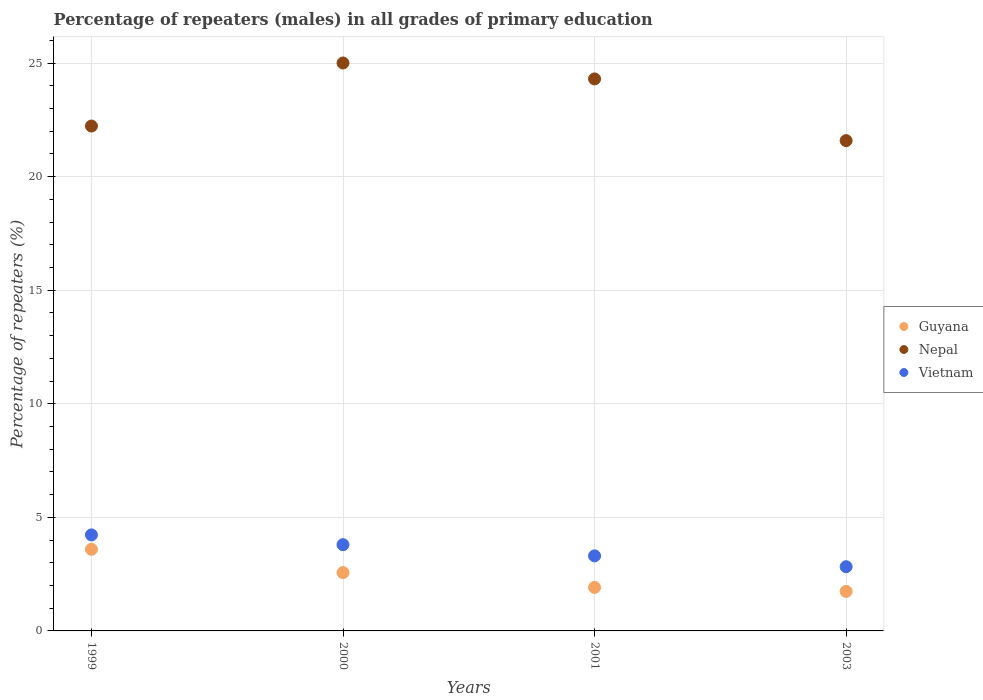How many different coloured dotlines are there?
Keep it short and to the point. 3. What is the percentage of repeaters (males) in Guyana in 2000?
Ensure brevity in your answer.  2.57. Across all years, what is the maximum percentage of repeaters (males) in Guyana?
Make the answer very short. 3.59. Across all years, what is the minimum percentage of repeaters (males) in Guyana?
Make the answer very short. 1.74. In which year was the percentage of repeaters (males) in Guyana minimum?
Offer a very short reply. 2003. What is the total percentage of repeaters (males) in Nepal in the graph?
Your answer should be very brief. 93.11. What is the difference between the percentage of repeaters (males) in Vietnam in 1999 and that in 2001?
Your response must be concise. 0.92. What is the difference between the percentage of repeaters (males) in Guyana in 1999 and the percentage of repeaters (males) in Vietnam in 2001?
Keep it short and to the point. 0.29. What is the average percentage of repeaters (males) in Guyana per year?
Provide a succinct answer. 2.45. In the year 2000, what is the difference between the percentage of repeaters (males) in Nepal and percentage of repeaters (males) in Vietnam?
Give a very brief answer. 21.2. In how many years, is the percentage of repeaters (males) in Nepal greater than 22 %?
Offer a very short reply. 3. What is the ratio of the percentage of repeaters (males) in Vietnam in 1999 to that in 2003?
Provide a succinct answer. 1.5. Is the percentage of repeaters (males) in Guyana in 2000 less than that in 2003?
Provide a short and direct response. No. What is the difference between the highest and the second highest percentage of repeaters (males) in Guyana?
Keep it short and to the point. 1.02. What is the difference between the highest and the lowest percentage of repeaters (males) in Nepal?
Make the answer very short. 3.42. In how many years, is the percentage of repeaters (males) in Vietnam greater than the average percentage of repeaters (males) in Vietnam taken over all years?
Ensure brevity in your answer.  2. Is the sum of the percentage of repeaters (males) in Vietnam in 1999 and 2000 greater than the maximum percentage of repeaters (males) in Nepal across all years?
Make the answer very short. No. Is it the case that in every year, the sum of the percentage of repeaters (males) in Nepal and percentage of repeaters (males) in Vietnam  is greater than the percentage of repeaters (males) in Guyana?
Your response must be concise. Yes. Does the percentage of repeaters (males) in Vietnam monotonically increase over the years?
Keep it short and to the point. No. Is the percentage of repeaters (males) in Guyana strictly greater than the percentage of repeaters (males) in Nepal over the years?
Make the answer very short. No. Is the percentage of repeaters (males) in Vietnam strictly less than the percentage of repeaters (males) in Nepal over the years?
Offer a terse response. Yes. How many dotlines are there?
Your answer should be compact. 3. What is the difference between two consecutive major ticks on the Y-axis?
Offer a terse response. 5. Are the values on the major ticks of Y-axis written in scientific E-notation?
Ensure brevity in your answer.  No. Does the graph contain any zero values?
Offer a terse response. No. How are the legend labels stacked?
Ensure brevity in your answer.  Vertical. What is the title of the graph?
Your answer should be very brief. Percentage of repeaters (males) in all grades of primary education. Does "United States" appear as one of the legend labels in the graph?
Offer a very short reply. No. What is the label or title of the X-axis?
Give a very brief answer. Years. What is the label or title of the Y-axis?
Keep it short and to the point. Percentage of repeaters (%). What is the Percentage of repeaters (%) in Guyana in 1999?
Give a very brief answer. 3.59. What is the Percentage of repeaters (%) of Nepal in 1999?
Your answer should be very brief. 22.23. What is the Percentage of repeaters (%) of Vietnam in 1999?
Your response must be concise. 4.23. What is the Percentage of repeaters (%) of Guyana in 2000?
Your answer should be compact. 2.57. What is the Percentage of repeaters (%) in Nepal in 2000?
Offer a very short reply. 25. What is the Percentage of repeaters (%) of Vietnam in 2000?
Make the answer very short. 3.8. What is the Percentage of repeaters (%) in Guyana in 2001?
Your response must be concise. 1.92. What is the Percentage of repeaters (%) in Nepal in 2001?
Give a very brief answer. 24.3. What is the Percentage of repeaters (%) of Vietnam in 2001?
Provide a short and direct response. 3.3. What is the Percentage of repeaters (%) in Guyana in 2003?
Your answer should be very brief. 1.74. What is the Percentage of repeaters (%) of Nepal in 2003?
Keep it short and to the point. 21.58. What is the Percentage of repeaters (%) in Vietnam in 2003?
Your response must be concise. 2.83. Across all years, what is the maximum Percentage of repeaters (%) in Guyana?
Your answer should be compact. 3.59. Across all years, what is the maximum Percentage of repeaters (%) in Nepal?
Ensure brevity in your answer.  25. Across all years, what is the maximum Percentage of repeaters (%) in Vietnam?
Your answer should be very brief. 4.23. Across all years, what is the minimum Percentage of repeaters (%) in Guyana?
Make the answer very short. 1.74. Across all years, what is the minimum Percentage of repeaters (%) of Nepal?
Provide a succinct answer. 21.58. Across all years, what is the minimum Percentage of repeaters (%) in Vietnam?
Ensure brevity in your answer.  2.83. What is the total Percentage of repeaters (%) of Guyana in the graph?
Offer a terse response. 9.82. What is the total Percentage of repeaters (%) in Nepal in the graph?
Ensure brevity in your answer.  93.11. What is the total Percentage of repeaters (%) of Vietnam in the graph?
Keep it short and to the point. 14.16. What is the difference between the Percentage of repeaters (%) of Nepal in 1999 and that in 2000?
Give a very brief answer. -2.78. What is the difference between the Percentage of repeaters (%) in Vietnam in 1999 and that in 2000?
Keep it short and to the point. 0.43. What is the difference between the Percentage of repeaters (%) of Guyana in 1999 and that in 2001?
Provide a succinct answer. 1.68. What is the difference between the Percentage of repeaters (%) in Nepal in 1999 and that in 2001?
Ensure brevity in your answer.  -2.08. What is the difference between the Percentage of repeaters (%) in Vietnam in 1999 and that in 2001?
Your answer should be compact. 0.92. What is the difference between the Percentage of repeaters (%) in Guyana in 1999 and that in 2003?
Offer a very short reply. 1.85. What is the difference between the Percentage of repeaters (%) of Nepal in 1999 and that in 2003?
Your answer should be compact. 0.64. What is the difference between the Percentage of repeaters (%) of Vietnam in 1999 and that in 2003?
Your response must be concise. 1.4. What is the difference between the Percentage of repeaters (%) of Guyana in 2000 and that in 2001?
Offer a very short reply. 0.65. What is the difference between the Percentage of repeaters (%) in Nepal in 2000 and that in 2001?
Offer a very short reply. 0.7. What is the difference between the Percentage of repeaters (%) of Vietnam in 2000 and that in 2001?
Offer a terse response. 0.49. What is the difference between the Percentage of repeaters (%) in Guyana in 2000 and that in 2003?
Provide a succinct answer. 0.83. What is the difference between the Percentage of repeaters (%) of Nepal in 2000 and that in 2003?
Provide a succinct answer. 3.42. What is the difference between the Percentage of repeaters (%) in Vietnam in 2000 and that in 2003?
Provide a short and direct response. 0.97. What is the difference between the Percentage of repeaters (%) in Guyana in 2001 and that in 2003?
Provide a succinct answer. 0.18. What is the difference between the Percentage of repeaters (%) in Nepal in 2001 and that in 2003?
Your answer should be very brief. 2.72. What is the difference between the Percentage of repeaters (%) in Vietnam in 2001 and that in 2003?
Your answer should be compact. 0.48. What is the difference between the Percentage of repeaters (%) in Guyana in 1999 and the Percentage of repeaters (%) in Nepal in 2000?
Keep it short and to the point. -21.41. What is the difference between the Percentage of repeaters (%) of Guyana in 1999 and the Percentage of repeaters (%) of Vietnam in 2000?
Provide a short and direct response. -0.2. What is the difference between the Percentage of repeaters (%) of Nepal in 1999 and the Percentage of repeaters (%) of Vietnam in 2000?
Provide a short and direct response. 18.43. What is the difference between the Percentage of repeaters (%) in Guyana in 1999 and the Percentage of repeaters (%) in Nepal in 2001?
Make the answer very short. -20.71. What is the difference between the Percentage of repeaters (%) of Guyana in 1999 and the Percentage of repeaters (%) of Vietnam in 2001?
Your answer should be compact. 0.29. What is the difference between the Percentage of repeaters (%) in Nepal in 1999 and the Percentage of repeaters (%) in Vietnam in 2001?
Provide a succinct answer. 18.92. What is the difference between the Percentage of repeaters (%) in Guyana in 1999 and the Percentage of repeaters (%) in Nepal in 2003?
Keep it short and to the point. -17.99. What is the difference between the Percentage of repeaters (%) in Guyana in 1999 and the Percentage of repeaters (%) in Vietnam in 2003?
Provide a short and direct response. 0.77. What is the difference between the Percentage of repeaters (%) in Nepal in 1999 and the Percentage of repeaters (%) in Vietnam in 2003?
Give a very brief answer. 19.4. What is the difference between the Percentage of repeaters (%) in Guyana in 2000 and the Percentage of repeaters (%) in Nepal in 2001?
Provide a succinct answer. -21.73. What is the difference between the Percentage of repeaters (%) of Guyana in 2000 and the Percentage of repeaters (%) of Vietnam in 2001?
Ensure brevity in your answer.  -0.74. What is the difference between the Percentage of repeaters (%) of Nepal in 2000 and the Percentage of repeaters (%) of Vietnam in 2001?
Your answer should be compact. 21.7. What is the difference between the Percentage of repeaters (%) in Guyana in 2000 and the Percentage of repeaters (%) in Nepal in 2003?
Offer a very short reply. -19.02. What is the difference between the Percentage of repeaters (%) in Guyana in 2000 and the Percentage of repeaters (%) in Vietnam in 2003?
Make the answer very short. -0.26. What is the difference between the Percentage of repeaters (%) in Nepal in 2000 and the Percentage of repeaters (%) in Vietnam in 2003?
Provide a short and direct response. 22.18. What is the difference between the Percentage of repeaters (%) in Guyana in 2001 and the Percentage of repeaters (%) in Nepal in 2003?
Provide a succinct answer. -19.67. What is the difference between the Percentage of repeaters (%) of Guyana in 2001 and the Percentage of repeaters (%) of Vietnam in 2003?
Ensure brevity in your answer.  -0.91. What is the difference between the Percentage of repeaters (%) of Nepal in 2001 and the Percentage of repeaters (%) of Vietnam in 2003?
Offer a terse response. 21.47. What is the average Percentage of repeaters (%) in Guyana per year?
Provide a short and direct response. 2.45. What is the average Percentage of repeaters (%) in Nepal per year?
Provide a short and direct response. 23.28. What is the average Percentage of repeaters (%) in Vietnam per year?
Your answer should be compact. 3.54. In the year 1999, what is the difference between the Percentage of repeaters (%) of Guyana and Percentage of repeaters (%) of Nepal?
Offer a terse response. -18.63. In the year 1999, what is the difference between the Percentage of repeaters (%) of Guyana and Percentage of repeaters (%) of Vietnam?
Your answer should be compact. -0.64. In the year 1999, what is the difference between the Percentage of repeaters (%) of Nepal and Percentage of repeaters (%) of Vietnam?
Offer a terse response. 18. In the year 2000, what is the difference between the Percentage of repeaters (%) in Guyana and Percentage of repeaters (%) in Nepal?
Provide a succinct answer. -22.43. In the year 2000, what is the difference between the Percentage of repeaters (%) in Guyana and Percentage of repeaters (%) in Vietnam?
Your response must be concise. -1.23. In the year 2000, what is the difference between the Percentage of repeaters (%) of Nepal and Percentage of repeaters (%) of Vietnam?
Offer a terse response. 21.2. In the year 2001, what is the difference between the Percentage of repeaters (%) in Guyana and Percentage of repeaters (%) in Nepal?
Offer a terse response. -22.39. In the year 2001, what is the difference between the Percentage of repeaters (%) of Guyana and Percentage of repeaters (%) of Vietnam?
Ensure brevity in your answer.  -1.39. In the year 2001, what is the difference between the Percentage of repeaters (%) in Nepal and Percentage of repeaters (%) in Vietnam?
Your answer should be very brief. 21. In the year 2003, what is the difference between the Percentage of repeaters (%) of Guyana and Percentage of repeaters (%) of Nepal?
Your response must be concise. -19.84. In the year 2003, what is the difference between the Percentage of repeaters (%) in Guyana and Percentage of repeaters (%) in Vietnam?
Ensure brevity in your answer.  -1.09. In the year 2003, what is the difference between the Percentage of repeaters (%) of Nepal and Percentage of repeaters (%) of Vietnam?
Your answer should be compact. 18.76. What is the ratio of the Percentage of repeaters (%) of Guyana in 1999 to that in 2000?
Provide a short and direct response. 1.4. What is the ratio of the Percentage of repeaters (%) in Nepal in 1999 to that in 2000?
Your answer should be compact. 0.89. What is the ratio of the Percentage of repeaters (%) of Vietnam in 1999 to that in 2000?
Your answer should be compact. 1.11. What is the ratio of the Percentage of repeaters (%) in Guyana in 1999 to that in 2001?
Ensure brevity in your answer.  1.88. What is the ratio of the Percentage of repeaters (%) in Nepal in 1999 to that in 2001?
Your answer should be compact. 0.91. What is the ratio of the Percentage of repeaters (%) of Vietnam in 1999 to that in 2001?
Your response must be concise. 1.28. What is the ratio of the Percentage of repeaters (%) of Guyana in 1999 to that in 2003?
Provide a short and direct response. 2.06. What is the ratio of the Percentage of repeaters (%) in Nepal in 1999 to that in 2003?
Your answer should be compact. 1.03. What is the ratio of the Percentage of repeaters (%) in Vietnam in 1999 to that in 2003?
Ensure brevity in your answer.  1.5. What is the ratio of the Percentage of repeaters (%) of Guyana in 2000 to that in 2001?
Your answer should be very brief. 1.34. What is the ratio of the Percentage of repeaters (%) in Nepal in 2000 to that in 2001?
Your response must be concise. 1.03. What is the ratio of the Percentage of repeaters (%) in Vietnam in 2000 to that in 2001?
Your answer should be very brief. 1.15. What is the ratio of the Percentage of repeaters (%) in Guyana in 2000 to that in 2003?
Your answer should be very brief. 1.48. What is the ratio of the Percentage of repeaters (%) of Nepal in 2000 to that in 2003?
Make the answer very short. 1.16. What is the ratio of the Percentage of repeaters (%) of Vietnam in 2000 to that in 2003?
Provide a succinct answer. 1.34. What is the ratio of the Percentage of repeaters (%) in Guyana in 2001 to that in 2003?
Offer a very short reply. 1.1. What is the ratio of the Percentage of repeaters (%) in Nepal in 2001 to that in 2003?
Ensure brevity in your answer.  1.13. What is the ratio of the Percentage of repeaters (%) in Vietnam in 2001 to that in 2003?
Your answer should be very brief. 1.17. What is the difference between the highest and the second highest Percentage of repeaters (%) of Nepal?
Offer a very short reply. 0.7. What is the difference between the highest and the second highest Percentage of repeaters (%) of Vietnam?
Offer a terse response. 0.43. What is the difference between the highest and the lowest Percentage of repeaters (%) of Guyana?
Your answer should be compact. 1.85. What is the difference between the highest and the lowest Percentage of repeaters (%) of Nepal?
Your answer should be very brief. 3.42. What is the difference between the highest and the lowest Percentage of repeaters (%) in Vietnam?
Your response must be concise. 1.4. 